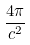<formula> <loc_0><loc_0><loc_500><loc_500>\frac { 4 \pi } { c ^ { 2 } }</formula> 